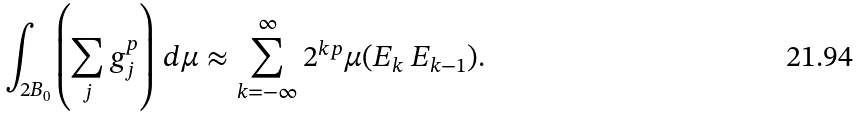<formula> <loc_0><loc_0><loc_500><loc_500>\int _ { 2 B _ { 0 } } \left ( \sum _ { j } g _ { j } ^ { p } \right ) \, d \mu \approx \sum _ { k = - \infty } ^ { \infty } 2 ^ { k p } \mu ( E _ { k } \ E _ { k - 1 } ) .</formula> 